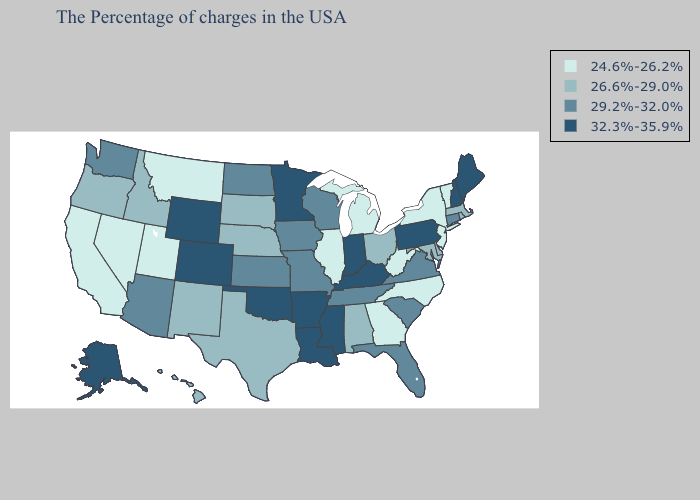Name the states that have a value in the range 26.6%-29.0%?
Keep it brief. Massachusetts, Rhode Island, Delaware, Maryland, Ohio, Alabama, Nebraska, Texas, South Dakota, New Mexico, Idaho, Oregon, Hawaii. Does West Virginia have the lowest value in the USA?
Answer briefly. Yes. Among the states that border Ohio , does Michigan have the highest value?
Give a very brief answer. No. Does Massachusetts have the lowest value in the USA?
Quick response, please. No. Name the states that have a value in the range 24.6%-26.2%?
Short answer required. Vermont, New York, New Jersey, North Carolina, West Virginia, Georgia, Michigan, Illinois, Utah, Montana, Nevada, California. Among the states that border Wyoming , which have the lowest value?
Answer briefly. Utah, Montana. What is the value of New Mexico?
Write a very short answer. 26.6%-29.0%. What is the value of Arkansas?
Give a very brief answer. 32.3%-35.9%. Among the states that border New Jersey , which have the lowest value?
Give a very brief answer. New York. What is the value of Iowa?
Give a very brief answer. 29.2%-32.0%. What is the highest value in the South ?
Give a very brief answer. 32.3%-35.9%. What is the value of New Hampshire?
Be succinct. 32.3%-35.9%. Name the states that have a value in the range 26.6%-29.0%?
Keep it brief. Massachusetts, Rhode Island, Delaware, Maryland, Ohio, Alabama, Nebraska, Texas, South Dakota, New Mexico, Idaho, Oregon, Hawaii. Does the map have missing data?
Answer briefly. No. What is the value of Texas?
Give a very brief answer. 26.6%-29.0%. 